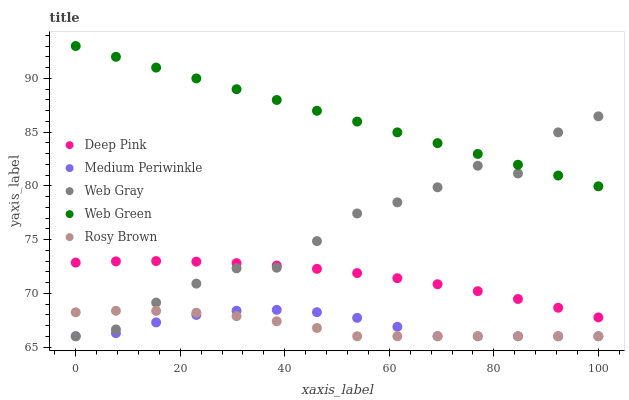Does Rosy Brown have the minimum area under the curve?
Answer yes or no. Yes. Does Web Green have the maximum area under the curve?
Answer yes or no. Yes. Does Deep Pink have the minimum area under the curve?
Answer yes or no. No. Does Deep Pink have the maximum area under the curve?
Answer yes or no. No. Is Web Green the smoothest?
Answer yes or no. Yes. Is Web Gray the roughest?
Answer yes or no. Yes. Is Rosy Brown the smoothest?
Answer yes or no. No. Is Rosy Brown the roughest?
Answer yes or no. No. Does Web Gray have the lowest value?
Answer yes or no. Yes. Does Deep Pink have the lowest value?
Answer yes or no. No. Does Web Green have the highest value?
Answer yes or no. Yes. Does Deep Pink have the highest value?
Answer yes or no. No. Is Medium Periwinkle less than Deep Pink?
Answer yes or no. Yes. Is Web Green greater than Rosy Brown?
Answer yes or no. Yes. Does Web Gray intersect Deep Pink?
Answer yes or no. Yes. Is Web Gray less than Deep Pink?
Answer yes or no. No. Is Web Gray greater than Deep Pink?
Answer yes or no. No. Does Medium Periwinkle intersect Deep Pink?
Answer yes or no. No. 